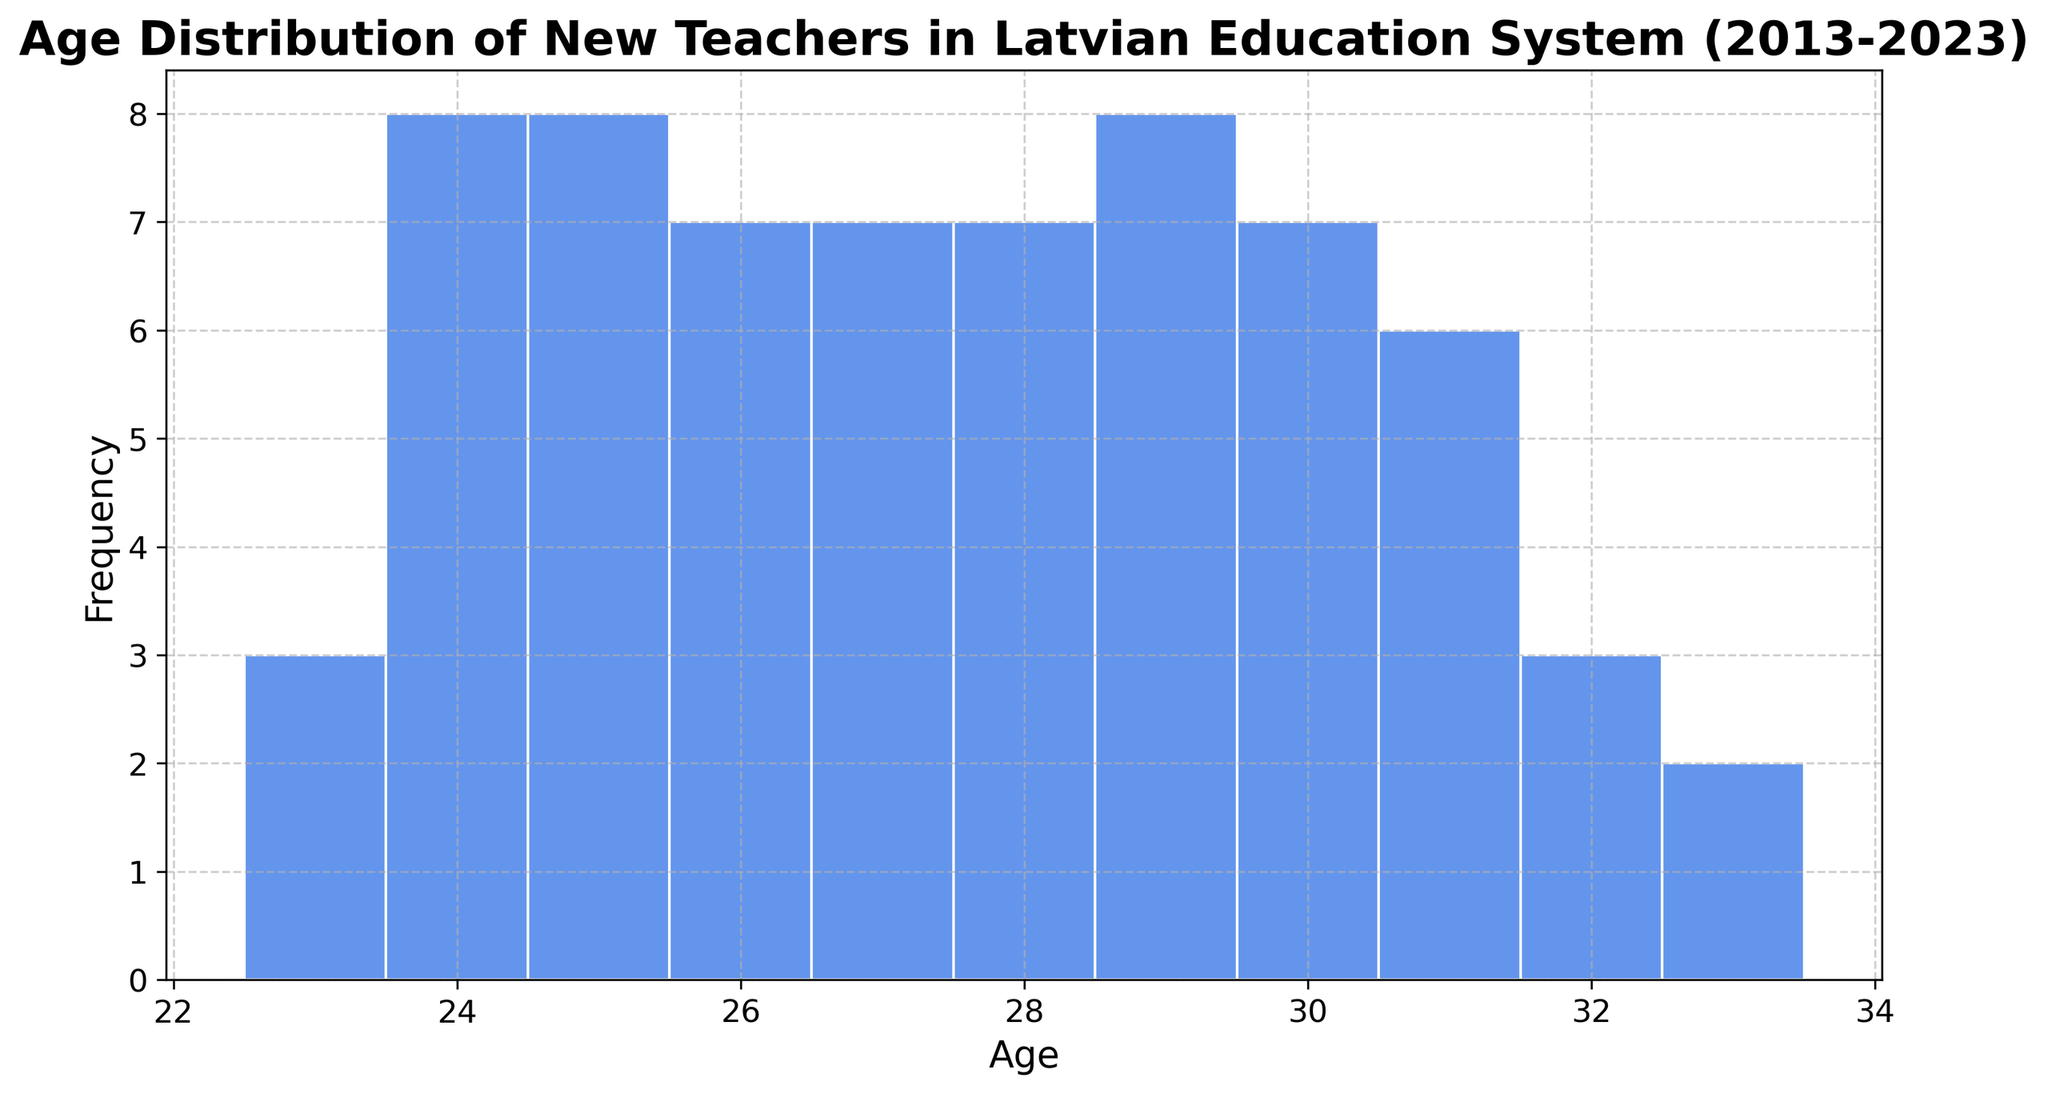What is the most common age of new teachers entering the Latvian education system between 2013 and 2023? To find the most common age, identify the tallest bar in the histogram and note the corresponding age.
Answer: 25 How many teachers are aged 24 during the observed period? Count the number of occurrences for age 24 from the histogram. The height of the bar corresponding to age 24 represents the frequency.
Answer: 7 Which age range has the highest frequency of new teachers? Determine the age range by looking for the consecutive ages that exhibit the highest frequencies together. Here, ages 25 to 29 display the tallest bars overall.
Answer: 25-29 Are there more teachers aged 30 or more teachers aged 29? Compare the heights of the bars corresponding to ages 30 and 29. The taller bar indicates more teachers.
Answer: 29 Which age has the least number of new teachers? Identify the shortest bar in the histogram and note the corresponding age.
Answer: 33 How does the frequency of teachers aged 26 compare to that of teachers aged 27? Compare the heights of the bars for ages 26 and 27 to see which is taller or if they are equal.
Answer: Age 27 has more teachers What is the average age of new teachers entering the system? Sum up the midpoints of the bars weighted by their frequencies, then divide by the total number of entries. This requires calculating the sums and frequencies. For a simplified example: (24*7 + 25*7 + 26*6 + 27*7 + 28*7 + 29*7 + 30*6 + 31*5 + 32*3 + 33*2)/57 = ~27.2
Answer: ~27.2 How does the number of teachers aged 23 compare to those aged 30? Count the number of teachers for both ages by looking at the heights of the bars. Compare the two counts.
Answer: Age 30 has more teachers Is there a notable trend in the ages of new teachers entering over the decade? Check if there is a visible overall increase or decrease in the ages over time, or if it remains relatively stable.
Answer: No clear trend What is the frequency range of new teachers in the histogram? Identify the minimum and maximum frequencies among all bars in the histogram.
Answer: 2 to 7 